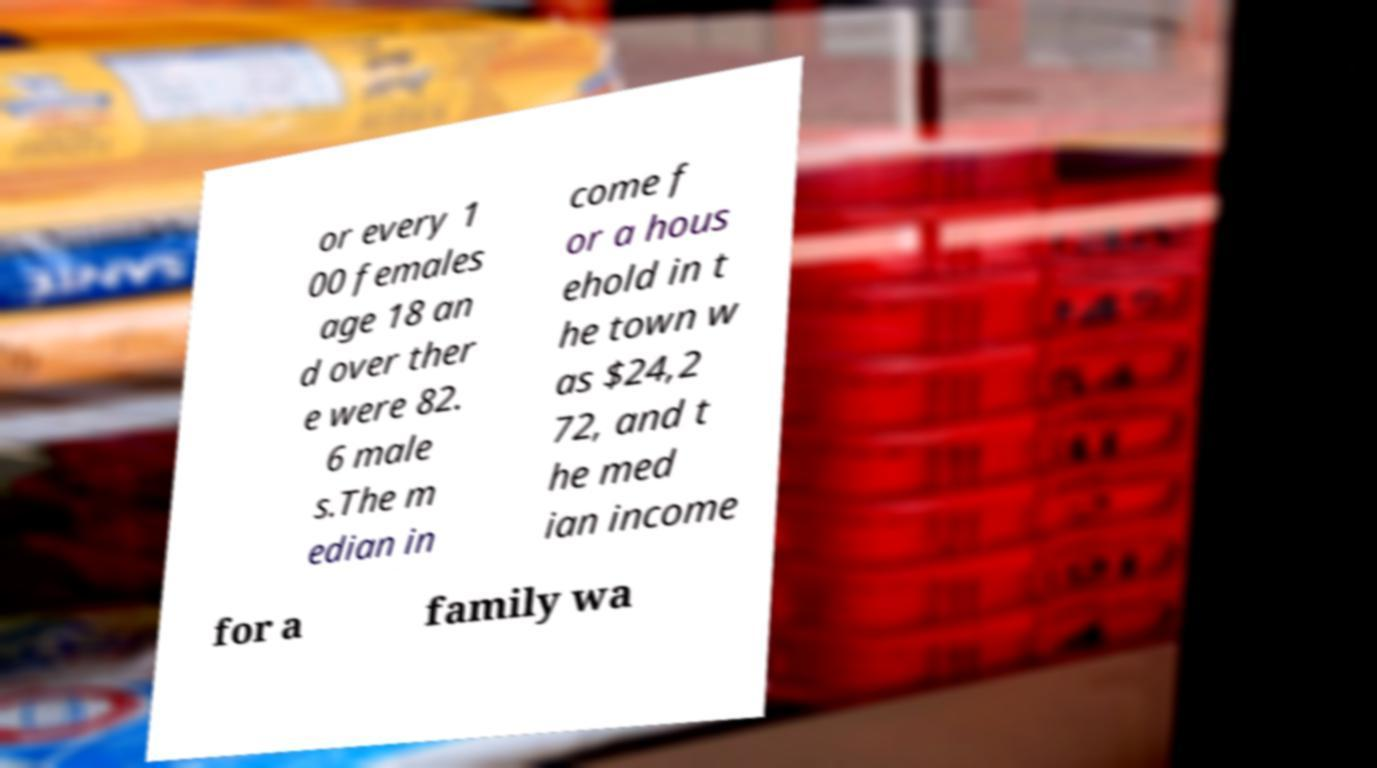For documentation purposes, I need the text within this image transcribed. Could you provide that? or every 1 00 females age 18 an d over ther e were 82. 6 male s.The m edian in come f or a hous ehold in t he town w as $24,2 72, and t he med ian income for a family wa 